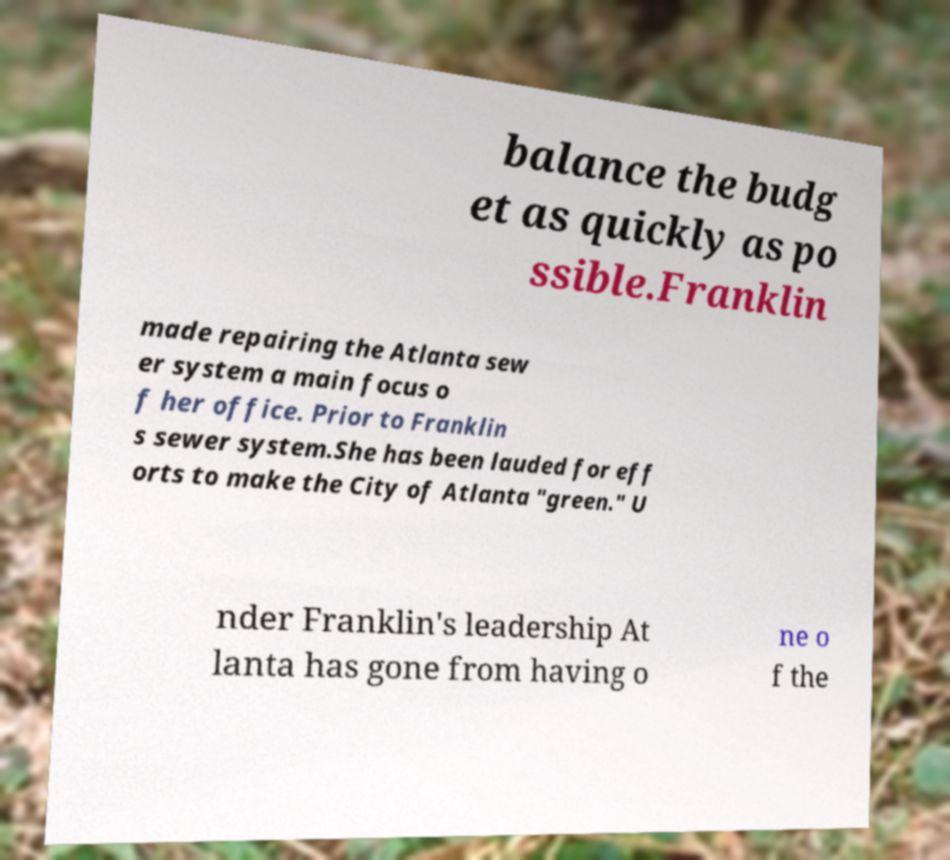Please read and relay the text visible in this image. What does it say? balance the budg et as quickly as po ssible.Franklin made repairing the Atlanta sew er system a main focus o f her office. Prior to Franklin s sewer system.She has been lauded for eff orts to make the City of Atlanta "green." U nder Franklin's leadership At lanta has gone from having o ne o f the 